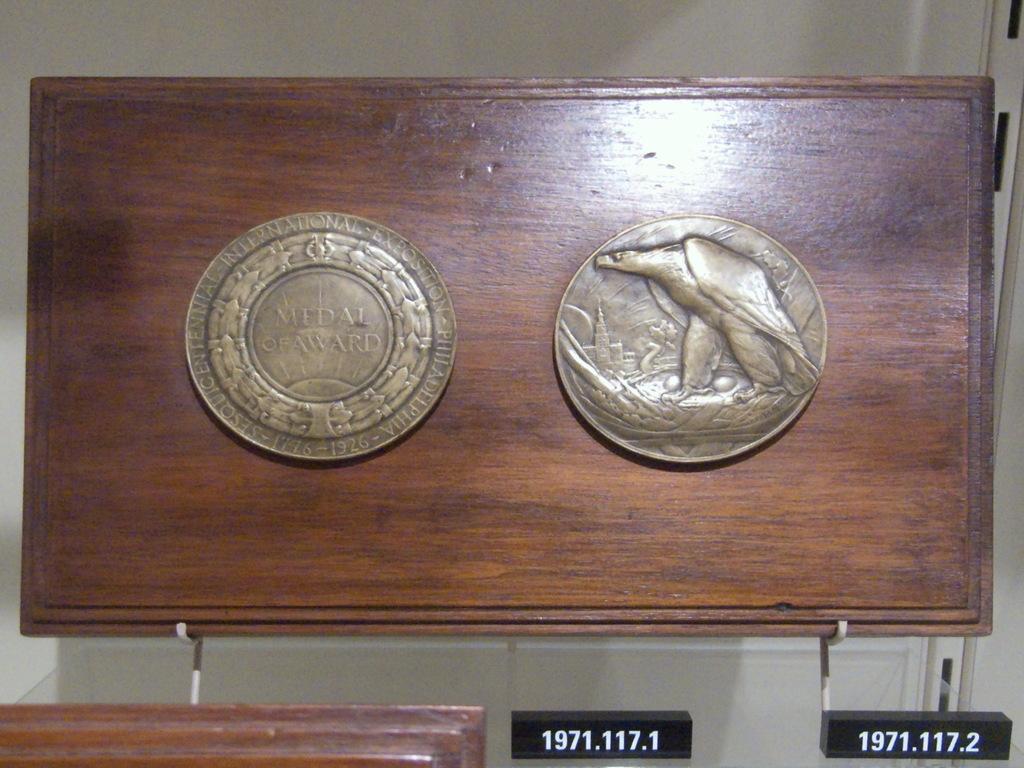What kind of medal is this?
Keep it short and to the point. Medal of award. What year is featured here?
Your response must be concise. 1971. 